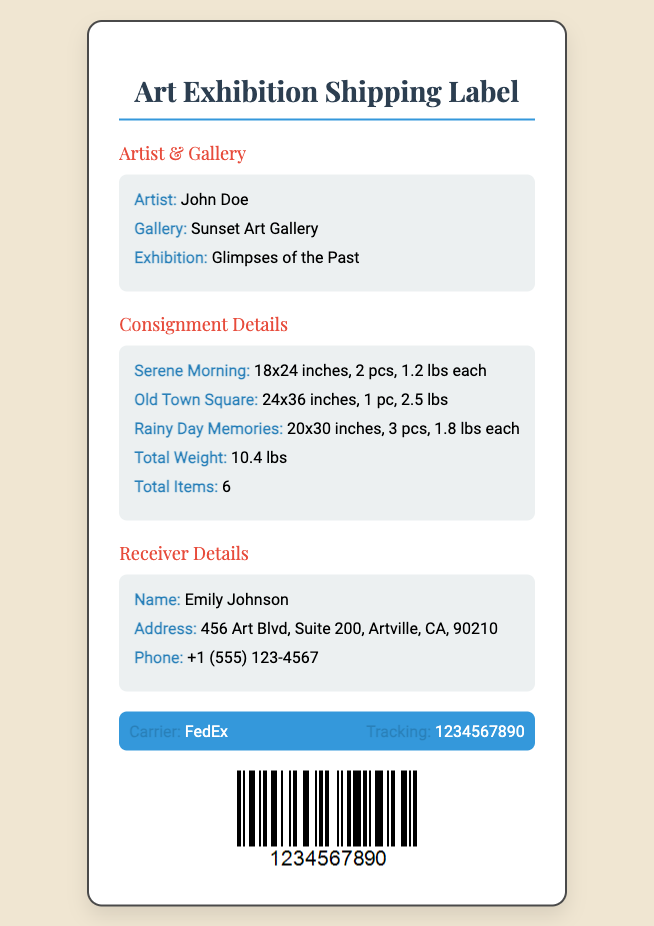What is the artist's name? The artist's name is listed in the document under the Artist section.
Answer: John Doe What is the total weight of the shipment? The total weight is mentioned in the Consignment Details section of the document.
Answer: 10.4 lbs How many pieces of art are being shipped? The total items shipped can be found in the Consignment Details section.
Answer: 6 What size is the artwork "Old Town Square"? The size of "Old Town Square" is provided in the Consignment Details section.
Answer: 24x36 inches Who is the receiver of the shipment? The receiver's name is indicated in the Receiver Details section.
Answer: Emily Johnson What shipping carrier is used for this consignment? The carrier information is presented in the Carrier Info section of the document.
Answer: FedEx How many pieces of "Rainy Day Memories" are included? The number of pieces for "Rainy Day Memories" is detailed in the Consignment Details section.
Answer: 3 pcs What is the phone number provided for the receiver? The phone number can be found in the Receiver Details section.
Answer: +1 (555) 123-4567 What is the exhibition title? The exhibition title is specified in the Artist & Gallery section.
Answer: Glimpses of the Past 